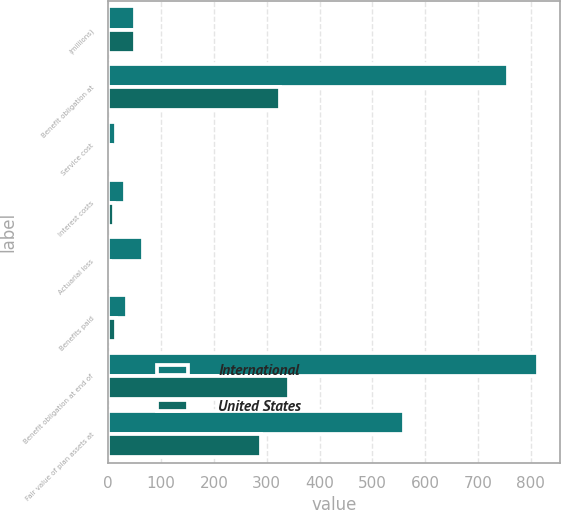<chart> <loc_0><loc_0><loc_500><loc_500><stacked_bar_chart><ecel><fcel>(millions)<fcel>Benefit obligation at<fcel>Service cost<fcel>Interest costs<fcel>Actuarial loss<fcel>Benefits paid<fcel>Benefit obligation at end of<fcel>Fair value of plan assets at<nl><fcel>International<fcel>50.4<fcel>757<fcel>14.8<fcel>31.7<fcel>65.6<fcel>35.2<fcel>813.7<fcel>558.9<nl><fcel>United States<fcel>50.4<fcel>324.9<fcel>6.2<fcel>10.4<fcel>3.3<fcel>15.3<fcel>341.5<fcel>289.1<nl></chart> 